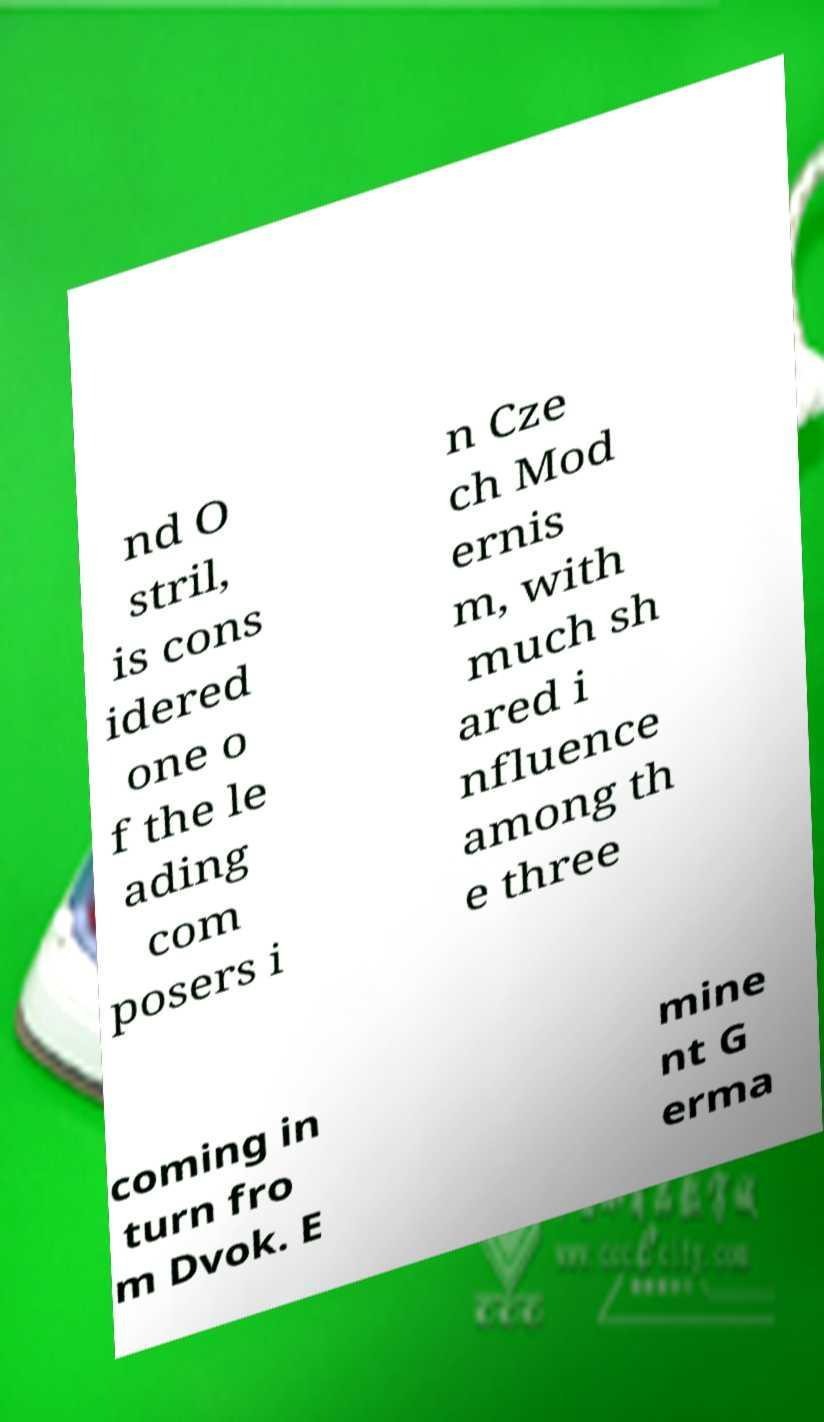Please identify and transcribe the text found in this image. nd O stril, is cons idered one o f the le ading com posers i n Cze ch Mod ernis m, with much sh ared i nfluence among th e three coming in turn fro m Dvok. E mine nt G erma 